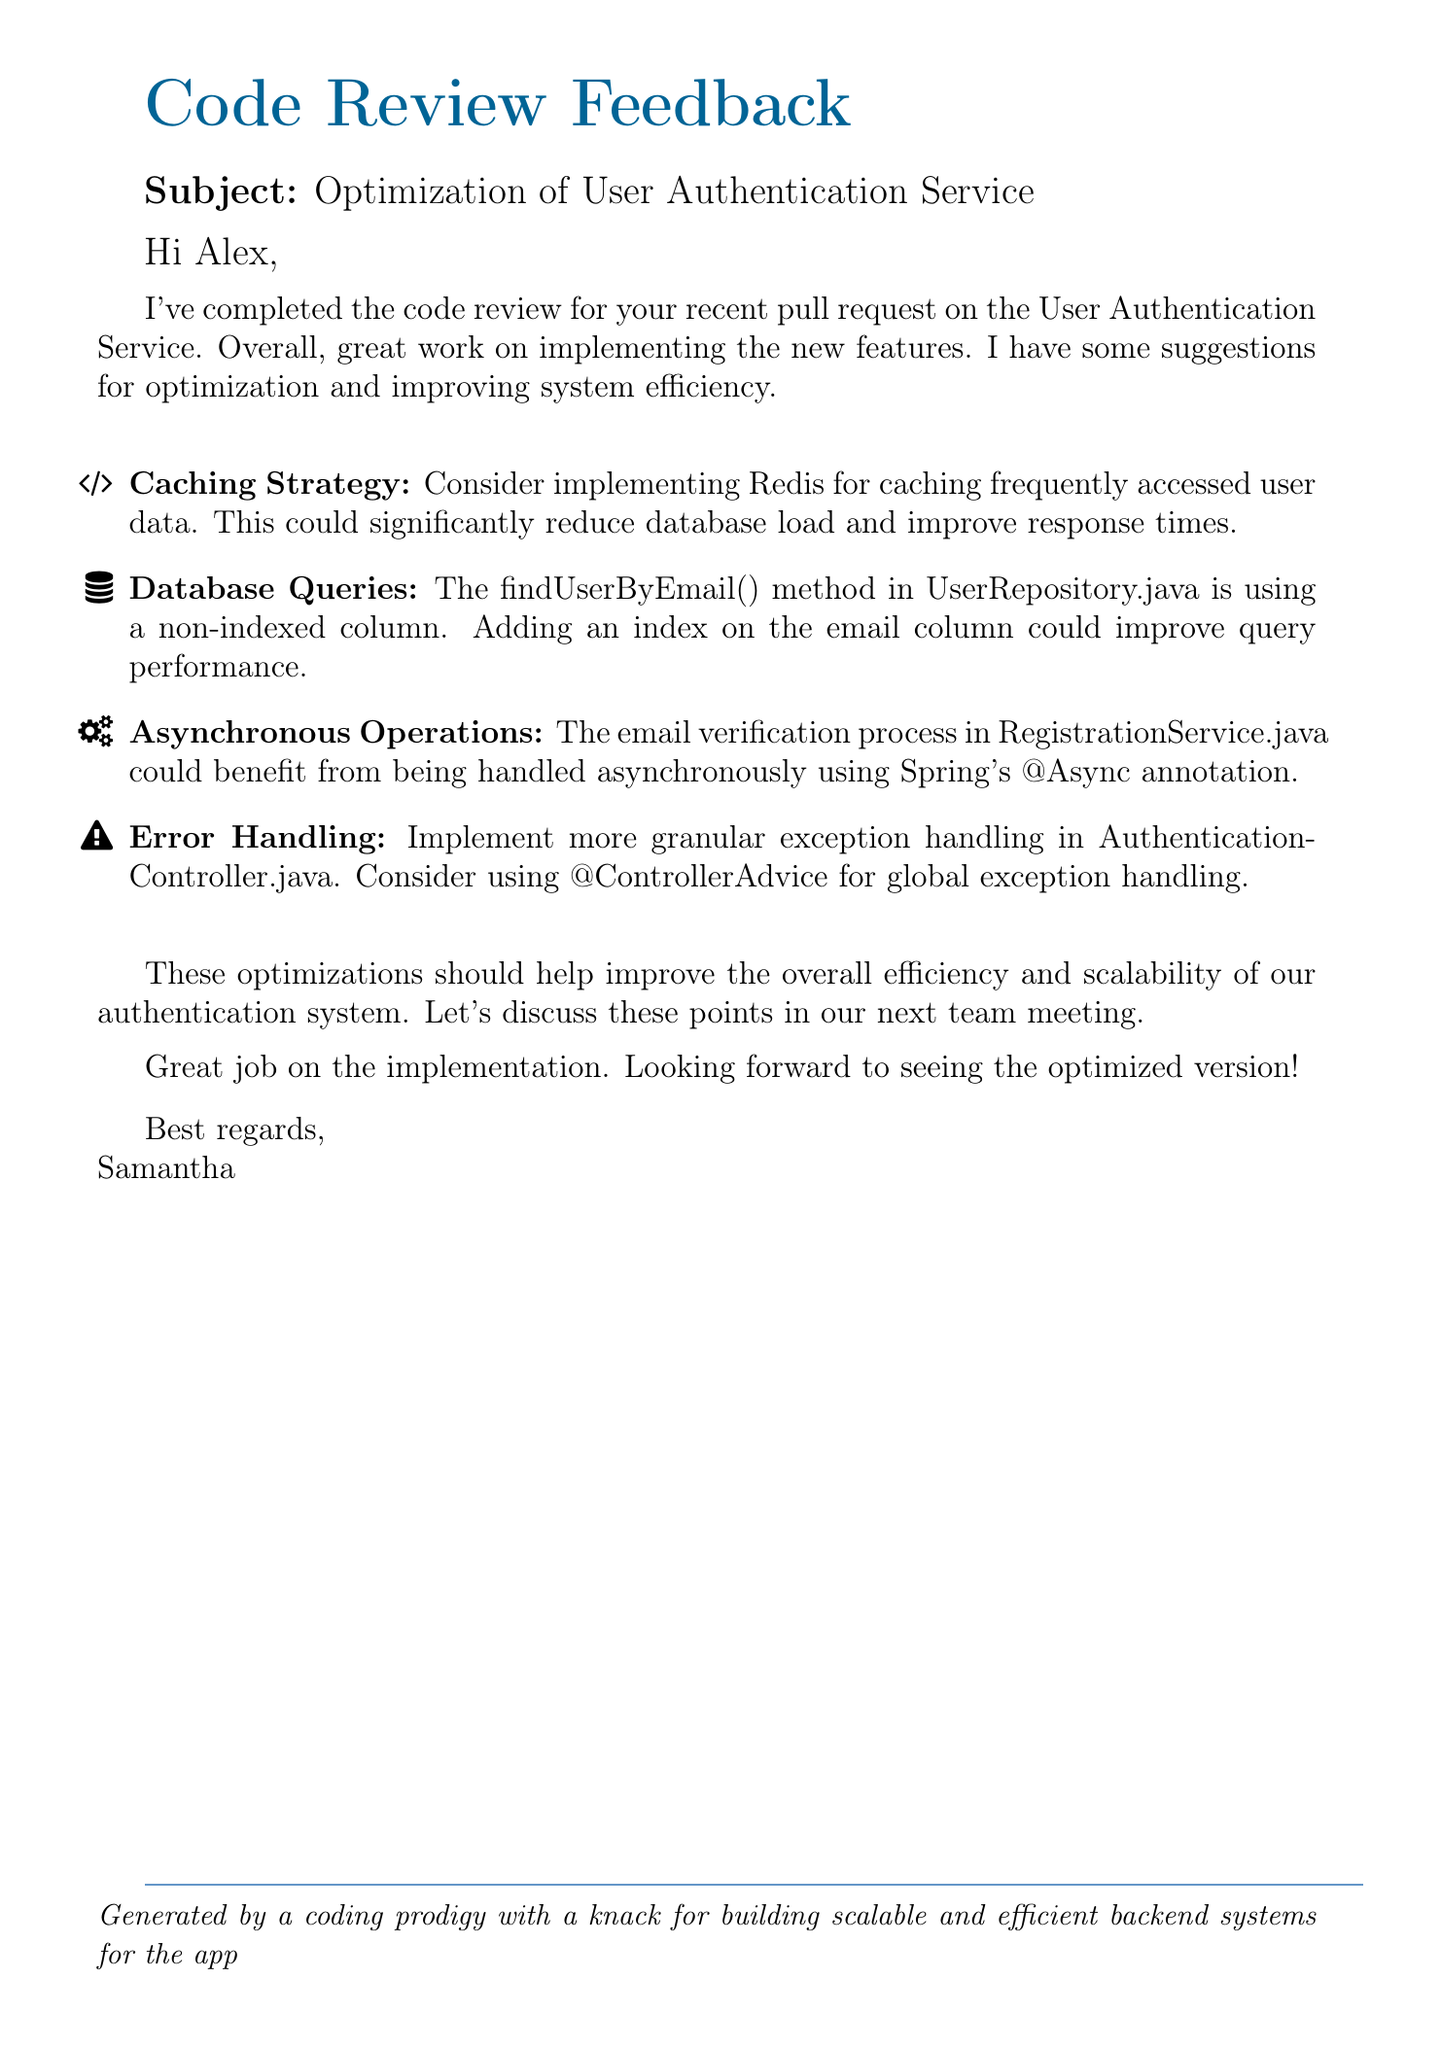What is the subject of the email? The subject is clearly stated in the document as the topic of discussion.
Answer: Optimization of User Authentication Service Who is the sender of the email? The sender's name is presented at the end of the document.
Answer: Samantha Which caching solution is suggested? The caching strategy section specifically mentions a technology for optimization.
Answer: Redis What method's performance is under discussion? The document references a specific method related to user queries.
Answer: findUserByEmail() What annotation is recommended for asynchronous operations? The document provides a specific annotation recommended for improving the email verification process.
Answer: @Async In which file is error handling suggested to be improved? The document specifies the name of the file where improvements for error handling are needed.
Answer: AuthenticationController.java What is the overall purpose of the email? The purpose is implied throughout the email and specifically stated in the conclusion.
Answer: Code review feedback How many areas for optimization are highlighted in the document? The number of key points listed provides this information.
Answer: Four 